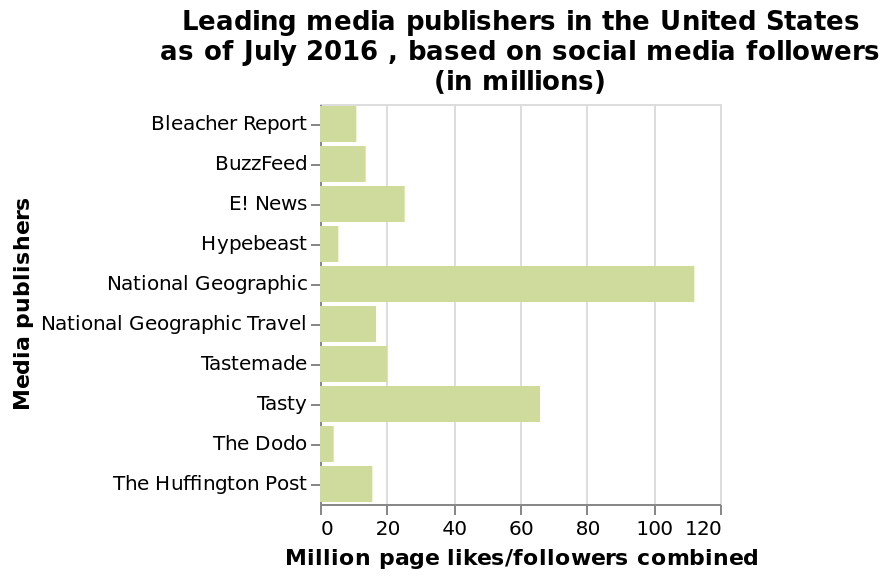<image>
please enumerates aspects of the construction of the chart Here a is a bar graph titled Leading media publishers in the United States as of July 2016 , based on social media followers (in millions). Million page likes/followers combined is plotted as a linear scale of range 0 to 120 along the x-axis. Along the y-axis, Media publishers is plotted using a categorical scale starting at Bleacher Report and ending at The Huffington Post. Which media publisher has the lowest number of followers?  The Dodo and Hypebeast have the lowest number of followers. What is the follower count for Hypebeast? Hypebeast has about 5 million followers.  What is plotted on the y-axis of the bar graph?  The y-axis of the bar graph is plotted with Media publishers, starting from Bleacher Report and ending at The Huffington Post. 